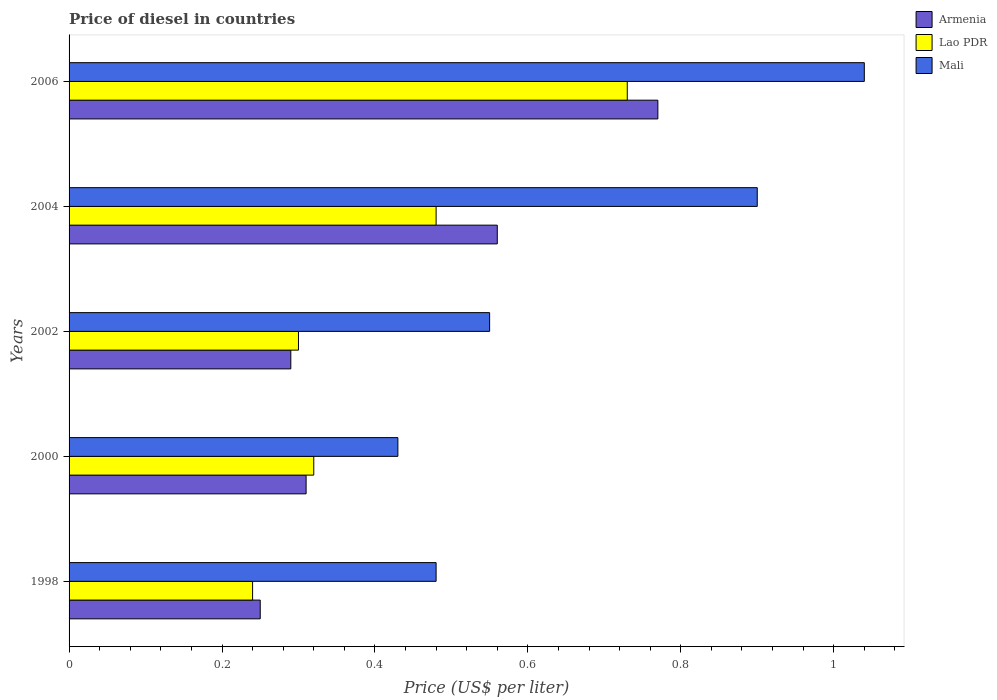How many groups of bars are there?
Offer a very short reply. 5. Are the number of bars per tick equal to the number of legend labels?
Ensure brevity in your answer.  Yes. Are the number of bars on each tick of the Y-axis equal?
Ensure brevity in your answer.  Yes. How many bars are there on the 2nd tick from the top?
Offer a terse response. 3. What is the label of the 2nd group of bars from the top?
Provide a short and direct response. 2004. Across all years, what is the maximum price of diesel in Armenia?
Your answer should be compact. 0.77. Across all years, what is the minimum price of diesel in Lao PDR?
Make the answer very short. 0.24. What is the total price of diesel in Mali in the graph?
Your response must be concise. 3.4. What is the difference between the price of diesel in Lao PDR in 1998 and that in 2004?
Provide a succinct answer. -0.24. What is the difference between the price of diesel in Lao PDR in 2004 and the price of diesel in Mali in 2002?
Provide a succinct answer. -0.07. What is the average price of diesel in Lao PDR per year?
Your answer should be very brief. 0.41. In the year 1998, what is the difference between the price of diesel in Lao PDR and price of diesel in Armenia?
Provide a succinct answer. -0.01. What is the ratio of the price of diesel in Mali in 1998 to that in 2004?
Your answer should be compact. 0.53. Is the difference between the price of diesel in Lao PDR in 2000 and 2004 greater than the difference between the price of diesel in Armenia in 2000 and 2004?
Give a very brief answer. Yes. What is the difference between the highest and the second highest price of diesel in Armenia?
Your response must be concise. 0.21. What is the difference between the highest and the lowest price of diesel in Armenia?
Make the answer very short. 0.52. In how many years, is the price of diesel in Mali greater than the average price of diesel in Mali taken over all years?
Your answer should be compact. 2. What does the 2nd bar from the top in 2000 represents?
Offer a very short reply. Lao PDR. What does the 1st bar from the bottom in 2006 represents?
Offer a very short reply. Armenia. Are all the bars in the graph horizontal?
Provide a succinct answer. Yes. Where does the legend appear in the graph?
Ensure brevity in your answer.  Top right. How many legend labels are there?
Keep it short and to the point. 3. How are the legend labels stacked?
Make the answer very short. Vertical. What is the title of the graph?
Offer a very short reply. Price of diesel in countries. Does "Suriname" appear as one of the legend labels in the graph?
Your answer should be very brief. No. What is the label or title of the X-axis?
Make the answer very short. Price (US$ per liter). What is the label or title of the Y-axis?
Give a very brief answer. Years. What is the Price (US$ per liter) of Lao PDR in 1998?
Your answer should be compact. 0.24. What is the Price (US$ per liter) of Mali in 1998?
Give a very brief answer. 0.48. What is the Price (US$ per liter) of Armenia in 2000?
Make the answer very short. 0.31. What is the Price (US$ per liter) of Lao PDR in 2000?
Your answer should be compact. 0.32. What is the Price (US$ per liter) of Mali in 2000?
Provide a succinct answer. 0.43. What is the Price (US$ per liter) of Armenia in 2002?
Your response must be concise. 0.29. What is the Price (US$ per liter) of Mali in 2002?
Give a very brief answer. 0.55. What is the Price (US$ per liter) in Armenia in 2004?
Your answer should be very brief. 0.56. What is the Price (US$ per liter) of Lao PDR in 2004?
Make the answer very short. 0.48. What is the Price (US$ per liter) in Mali in 2004?
Ensure brevity in your answer.  0.9. What is the Price (US$ per liter) in Armenia in 2006?
Give a very brief answer. 0.77. What is the Price (US$ per liter) in Lao PDR in 2006?
Offer a terse response. 0.73. Across all years, what is the maximum Price (US$ per liter) in Armenia?
Keep it short and to the point. 0.77. Across all years, what is the maximum Price (US$ per liter) of Lao PDR?
Keep it short and to the point. 0.73. Across all years, what is the maximum Price (US$ per liter) in Mali?
Provide a short and direct response. 1.04. Across all years, what is the minimum Price (US$ per liter) in Lao PDR?
Offer a terse response. 0.24. Across all years, what is the minimum Price (US$ per liter) in Mali?
Keep it short and to the point. 0.43. What is the total Price (US$ per liter) in Armenia in the graph?
Keep it short and to the point. 2.18. What is the total Price (US$ per liter) in Lao PDR in the graph?
Your answer should be very brief. 2.07. What is the total Price (US$ per liter) of Mali in the graph?
Your answer should be very brief. 3.4. What is the difference between the Price (US$ per liter) of Armenia in 1998 and that in 2000?
Make the answer very short. -0.06. What is the difference between the Price (US$ per liter) of Lao PDR in 1998 and that in 2000?
Your answer should be compact. -0.08. What is the difference between the Price (US$ per liter) in Mali in 1998 and that in 2000?
Provide a short and direct response. 0.05. What is the difference between the Price (US$ per liter) in Armenia in 1998 and that in 2002?
Offer a terse response. -0.04. What is the difference between the Price (US$ per liter) of Lao PDR in 1998 and that in 2002?
Your response must be concise. -0.06. What is the difference between the Price (US$ per liter) of Mali in 1998 and that in 2002?
Offer a terse response. -0.07. What is the difference between the Price (US$ per liter) of Armenia in 1998 and that in 2004?
Keep it short and to the point. -0.31. What is the difference between the Price (US$ per liter) of Lao PDR in 1998 and that in 2004?
Your answer should be very brief. -0.24. What is the difference between the Price (US$ per liter) of Mali in 1998 and that in 2004?
Your answer should be compact. -0.42. What is the difference between the Price (US$ per liter) of Armenia in 1998 and that in 2006?
Provide a succinct answer. -0.52. What is the difference between the Price (US$ per liter) of Lao PDR in 1998 and that in 2006?
Offer a terse response. -0.49. What is the difference between the Price (US$ per liter) of Mali in 1998 and that in 2006?
Provide a succinct answer. -0.56. What is the difference between the Price (US$ per liter) in Lao PDR in 2000 and that in 2002?
Offer a terse response. 0.02. What is the difference between the Price (US$ per liter) of Mali in 2000 and that in 2002?
Offer a very short reply. -0.12. What is the difference between the Price (US$ per liter) in Armenia in 2000 and that in 2004?
Your answer should be very brief. -0.25. What is the difference between the Price (US$ per liter) in Lao PDR in 2000 and that in 2004?
Make the answer very short. -0.16. What is the difference between the Price (US$ per liter) of Mali in 2000 and that in 2004?
Give a very brief answer. -0.47. What is the difference between the Price (US$ per liter) of Armenia in 2000 and that in 2006?
Offer a terse response. -0.46. What is the difference between the Price (US$ per liter) of Lao PDR in 2000 and that in 2006?
Give a very brief answer. -0.41. What is the difference between the Price (US$ per liter) of Mali in 2000 and that in 2006?
Offer a terse response. -0.61. What is the difference between the Price (US$ per liter) in Armenia in 2002 and that in 2004?
Ensure brevity in your answer.  -0.27. What is the difference between the Price (US$ per liter) in Lao PDR in 2002 and that in 2004?
Ensure brevity in your answer.  -0.18. What is the difference between the Price (US$ per liter) in Mali in 2002 and that in 2004?
Your answer should be compact. -0.35. What is the difference between the Price (US$ per liter) in Armenia in 2002 and that in 2006?
Offer a very short reply. -0.48. What is the difference between the Price (US$ per liter) of Lao PDR in 2002 and that in 2006?
Keep it short and to the point. -0.43. What is the difference between the Price (US$ per liter) in Mali in 2002 and that in 2006?
Provide a short and direct response. -0.49. What is the difference between the Price (US$ per liter) in Armenia in 2004 and that in 2006?
Ensure brevity in your answer.  -0.21. What is the difference between the Price (US$ per liter) in Mali in 2004 and that in 2006?
Ensure brevity in your answer.  -0.14. What is the difference between the Price (US$ per liter) of Armenia in 1998 and the Price (US$ per liter) of Lao PDR in 2000?
Provide a short and direct response. -0.07. What is the difference between the Price (US$ per liter) in Armenia in 1998 and the Price (US$ per liter) in Mali in 2000?
Give a very brief answer. -0.18. What is the difference between the Price (US$ per liter) of Lao PDR in 1998 and the Price (US$ per liter) of Mali in 2000?
Give a very brief answer. -0.19. What is the difference between the Price (US$ per liter) of Lao PDR in 1998 and the Price (US$ per liter) of Mali in 2002?
Your response must be concise. -0.31. What is the difference between the Price (US$ per liter) in Armenia in 1998 and the Price (US$ per liter) in Lao PDR in 2004?
Offer a terse response. -0.23. What is the difference between the Price (US$ per liter) of Armenia in 1998 and the Price (US$ per liter) of Mali in 2004?
Your answer should be very brief. -0.65. What is the difference between the Price (US$ per liter) of Lao PDR in 1998 and the Price (US$ per liter) of Mali in 2004?
Provide a short and direct response. -0.66. What is the difference between the Price (US$ per liter) of Armenia in 1998 and the Price (US$ per liter) of Lao PDR in 2006?
Provide a succinct answer. -0.48. What is the difference between the Price (US$ per liter) of Armenia in 1998 and the Price (US$ per liter) of Mali in 2006?
Give a very brief answer. -0.79. What is the difference between the Price (US$ per liter) in Armenia in 2000 and the Price (US$ per liter) in Mali in 2002?
Offer a very short reply. -0.24. What is the difference between the Price (US$ per liter) of Lao PDR in 2000 and the Price (US$ per liter) of Mali in 2002?
Offer a terse response. -0.23. What is the difference between the Price (US$ per liter) in Armenia in 2000 and the Price (US$ per liter) in Lao PDR in 2004?
Provide a succinct answer. -0.17. What is the difference between the Price (US$ per liter) of Armenia in 2000 and the Price (US$ per liter) of Mali in 2004?
Your answer should be very brief. -0.59. What is the difference between the Price (US$ per liter) of Lao PDR in 2000 and the Price (US$ per liter) of Mali in 2004?
Your answer should be very brief. -0.58. What is the difference between the Price (US$ per liter) in Armenia in 2000 and the Price (US$ per liter) in Lao PDR in 2006?
Your answer should be compact. -0.42. What is the difference between the Price (US$ per liter) of Armenia in 2000 and the Price (US$ per liter) of Mali in 2006?
Give a very brief answer. -0.73. What is the difference between the Price (US$ per liter) in Lao PDR in 2000 and the Price (US$ per liter) in Mali in 2006?
Keep it short and to the point. -0.72. What is the difference between the Price (US$ per liter) in Armenia in 2002 and the Price (US$ per liter) in Lao PDR in 2004?
Offer a very short reply. -0.19. What is the difference between the Price (US$ per liter) in Armenia in 2002 and the Price (US$ per liter) in Mali in 2004?
Your answer should be very brief. -0.61. What is the difference between the Price (US$ per liter) of Lao PDR in 2002 and the Price (US$ per liter) of Mali in 2004?
Your response must be concise. -0.6. What is the difference between the Price (US$ per liter) of Armenia in 2002 and the Price (US$ per liter) of Lao PDR in 2006?
Provide a succinct answer. -0.44. What is the difference between the Price (US$ per liter) in Armenia in 2002 and the Price (US$ per liter) in Mali in 2006?
Your answer should be compact. -0.75. What is the difference between the Price (US$ per liter) of Lao PDR in 2002 and the Price (US$ per liter) of Mali in 2006?
Provide a succinct answer. -0.74. What is the difference between the Price (US$ per liter) of Armenia in 2004 and the Price (US$ per liter) of Lao PDR in 2006?
Offer a terse response. -0.17. What is the difference between the Price (US$ per liter) of Armenia in 2004 and the Price (US$ per liter) of Mali in 2006?
Provide a succinct answer. -0.48. What is the difference between the Price (US$ per liter) in Lao PDR in 2004 and the Price (US$ per liter) in Mali in 2006?
Your response must be concise. -0.56. What is the average Price (US$ per liter) in Armenia per year?
Your answer should be compact. 0.44. What is the average Price (US$ per liter) in Lao PDR per year?
Your answer should be very brief. 0.41. What is the average Price (US$ per liter) of Mali per year?
Ensure brevity in your answer.  0.68. In the year 1998, what is the difference between the Price (US$ per liter) in Armenia and Price (US$ per liter) in Mali?
Provide a short and direct response. -0.23. In the year 1998, what is the difference between the Price (US$ per liter) in Lao PDR and Price (US$ per liter) in Mali?
Your answer should be compact. -0.24. In the year 2000, what is the difference between the Price (US$ per liter) in Armenia and Price (US$ per liter) in Lao PDR?
Keep it short and to the point. -0.01. In the year 2000, what is the difference between the Price (US$ per liter) of Armenia and Price (US$ per liter) of Mali?
Make the answer very short. -0.12. In the year 2000, what is the difference between the Price (US$ per liter) of Lao PDR and Price (US$ per liter) of Mali?
Keep it short and to the point. -0.11. In the year 2002, what is the difference between the Price (US$ per liter) of Armenia and Price (US$ per liter) of Lao PDR?
Give a very brief answer. -0.01. In the year 2002, what is the difference between the Price (US$ per liter) of Armenia and Price (US$ per liter) of Mali?
Provide a short and direct response. -0.26. In the year 2004, what is the difference between the Price (US$ per liter) of Armenia and Price (US$ per liter) of Mali?
Your answer should be compact. -0.34. In the year 2004, what is the difference between the Price (US$ per liter) in Lao PDR and Price (US$ per liter) in Mali?
Ensure brevity in your answer.  -0.42. In the year 2006, what is the difference between the Price (US$ per liter) of Armenia and Price (US$ per liter) of Lao PDR?
Provide a succinct answer. 0.04. In the year 2006, what is the difference between the Price (US$ per liter) in Armenia and Price (US$ per liter) in Mali?
Your answer should be very brief. -0.27. In the year 2006, what is the difference between the Price (US$ per liter) in Lao PDR and Price (US$ per liter) in Mali?
Keep it short and to the point. -0.31. What is the ratio of the Price (US$ per liter) in Armenia in 1998 to that in 2000?
Provide a short and direct response. 0.81. What is the ratio of the Price (US$ per liter) in Mali in 1998 to that in 2000?
Your response must be concise. 1.12. What is the ratio of the Price (US$ per liter) of Armenia in 1998 to that in 2002?
Provide a short and direct response. 0.86. What is the ratio of the Price (US$ per liter) in Mali in 1998 to that in 2002?
Your response must be concise. 0.87. What is the ratio of the Price (US$ per liter) of Armenia in 1998 to that in 2004?
Provide a short and direct response. 0.45. What is the ratio of the Price (US$ per liter) of Lao PDR in 1998 to that in 2004?
Offer a terse response. 0.5. What is the ratio of the Price (US$ per liter) of Mali in 1998 to that in 2004?
Offer a very short reply. 0.53. What is the ratio of the Price (US$ per liter) of Armenia in 1998 to that in 2006?
Provide a short and direct response. 0.32. What is the ratio of the Price (US$ per liter) in Lao PDR in 1998 to that in 2006?
Offer a terse response. 0.33. What is the ratio of the Price (US$ per liter) of Mali in 1998 to that in 2006?
Your answer should be compact. 0.46. What is the ratio of the Price (US$ per liter) of Armenia in 2000 to that in 2002?
Your answer should be very brief. 1.07. What is the ratio of the Price (US$ per liter) in Lao PDR in 2000 to that in 2002?
Ensure brevity in your answer.  1.07. What is the ratio of the Price (US$ per liter) in Mali in 2000 to that in 2002?
Offer a very short reply. 0.78. What is the ratio of the Price (US$ per liter) of Armenia in 2000 to that in 2004?
Give a very brief answer. 0.55. What is the ratio of the Price (US$ per liter) in Lao PDR in 2000 to that in 2004?
Provide a short and direct response. 0.67. What is the ratio of the Price (US$ per liter) of Mali in 2000 to that in 2004?
Provide a succinct answer. 0.48. What is the ratio of the Price (US$ per liter) of Armenia in 2000 to that in 2006?
Ensure brevity in your answer.  0.4. What is the ratio of the Price (US$ per liter) in Lao PDR in 2000 to that in 2006?
Offer a very short reply. 0.44. What is the ratio of the Price (US$ per liter) of Mali in 2000 to that in 2006?
Your answer should be very brief. 0.41. What is the ratio of the Price (US$ per liter) in Armenia in 2002 to that in 2004?
Provide a succinct answer. 0.52. What is the ratio of the Price (US$ per liter) in Mali in 2002 to that in 2004?
Your response must be concise. 0.61. What is the ratio of the Price (US$ per liter) of Armenia in 2002 to that in 2006?
Provide a short and direct response. 0.38. What is the ratio of the Price (US$ per liter) of Lao PDR in 2002 to that in 2006?
Your answer should be very brief. 0.41. What is the ratio of the Price (US$ per liter) in Mali in 2002 to that in 2006?
Keep it short and to the point. 0.53. What is the ratio of the Price (US$ per liter) of Armenia in 2004 to that in 2006?
Provide a short and direct response. 0.73. What is the ratio of the Price (US$ per liter) of Lao PDR in 2004 to that in 2006?
Your answer should be compact. 0.66. What is the ratio of the Price (US$ per liter) of Mali in 2004 to that in 2006?
Offer a terse response. 0.87. What is the difference between the highest and the second highest Price (US$ per liter) in Armenia?
Provide a succinct answer. 0.21. What is the difference between the highest and the second highest Price (US$ per liter) in Mali?
Ensure brevity in your answer.  0.14. What is the difference between the highest and the lowest Price (US$ per liter) of Armenia?
Give a very brief answer. 0.52. What is the difference between the highest and the lowest Price (US$ per liter) of Lao PDR?
Ensure brevity in your answer.  0.49. What is the difference between the highest and the lowest Price (US$ per liter) of Mali?
Offer a very short reply. 0.61. 